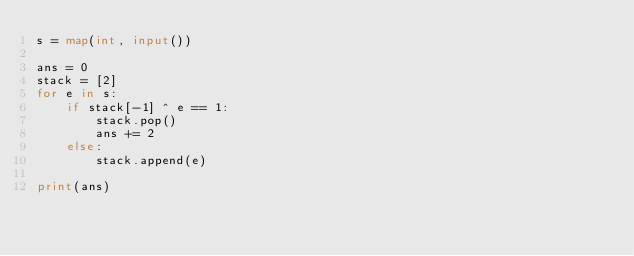Convert code to text. <code><loc_0><loc_0><loc_500><loc_500><_Python_>s = map(int, input())

ans = 0
stack = [2]
for e in s:
    if stack[-1] ^ e == 1:
        stack.pop()
        ans += 2
    else:
        stack.append(e)

print(ans)
</code> 